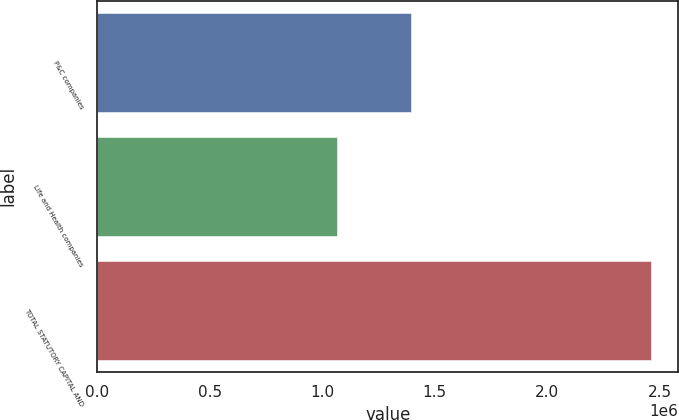<chart> <loc_0><loc_0><loc_500><loc_500><bar_chart><fcel>P&C companies<fcel>Life and Health companies<fcel>TOTAL STATUTORY CAPITAL AND<nl><fcel>1.3963e+06<fcel>1.06417e+06<fcel>2.46048e+06<nl></chart> 